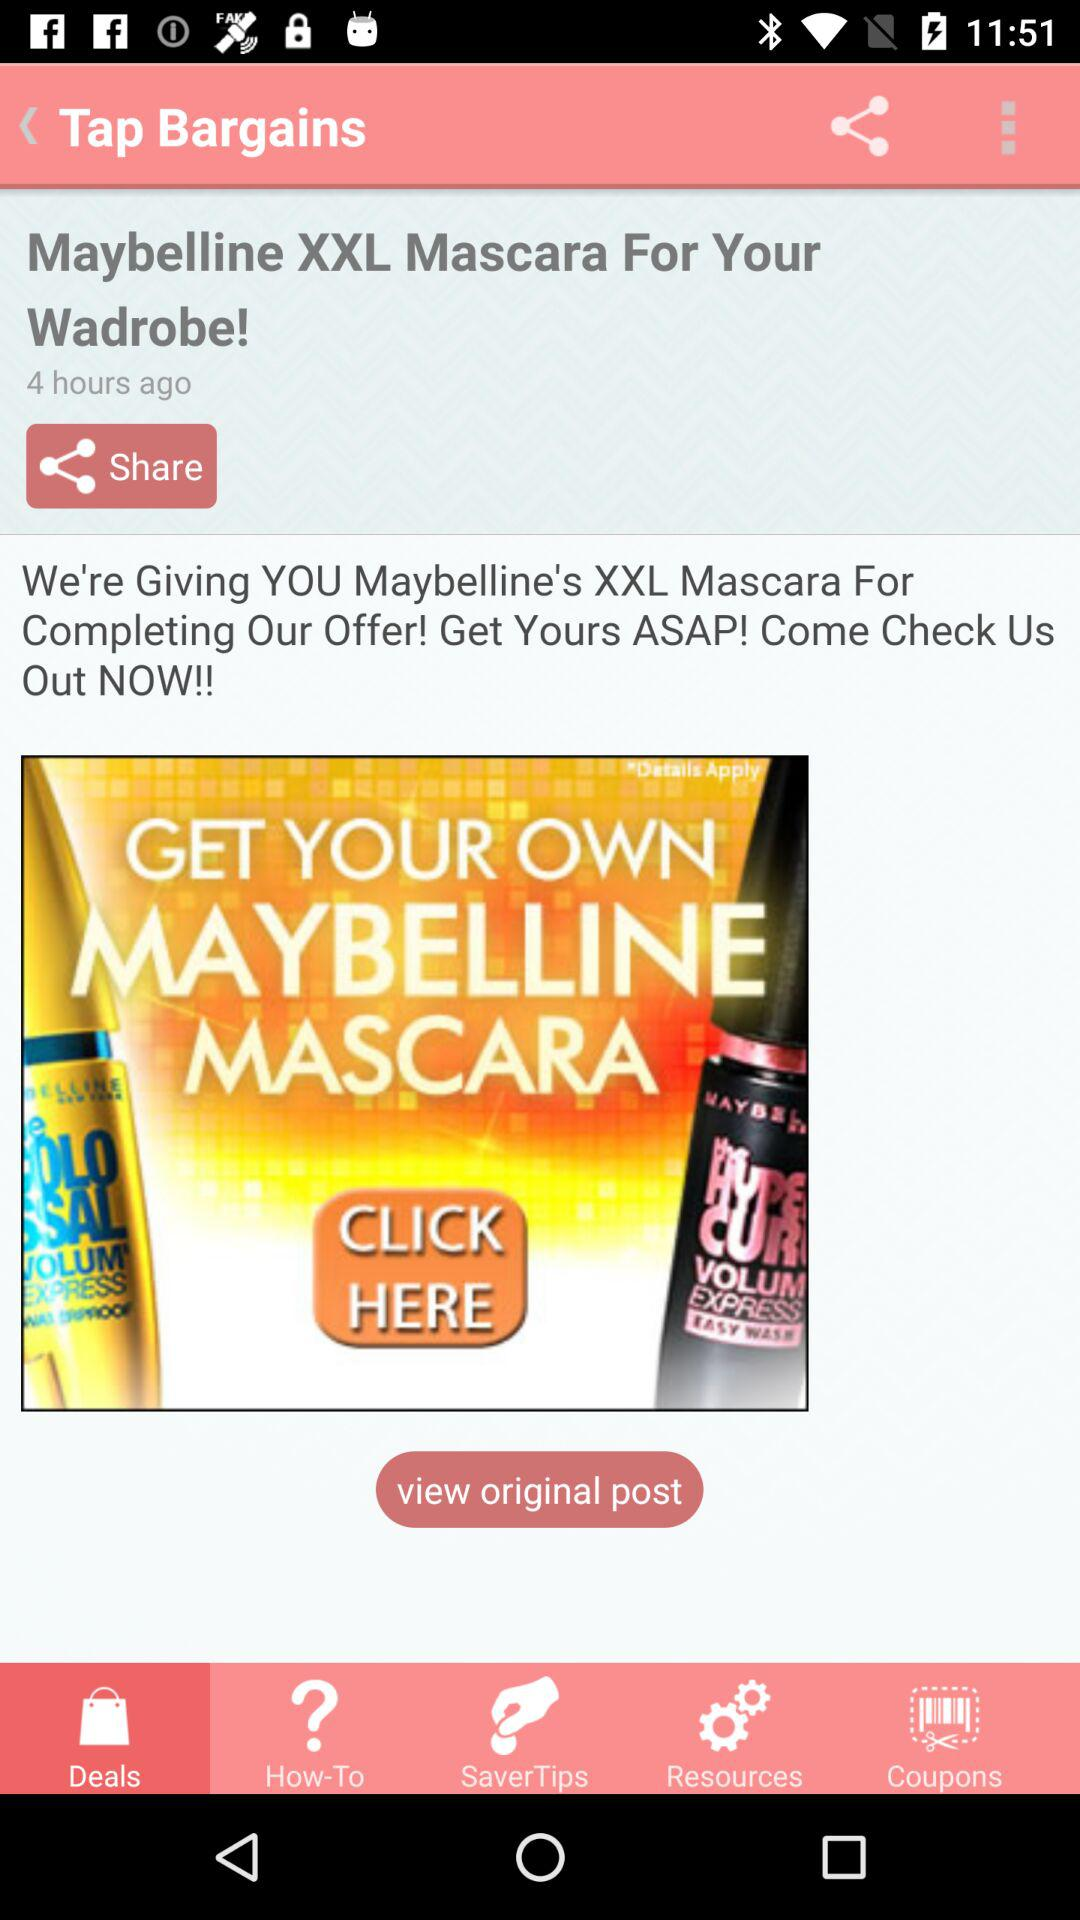How many "SaverTips" are there?
When the provided information is insufficient, respond with <no answer>. <no answer> 